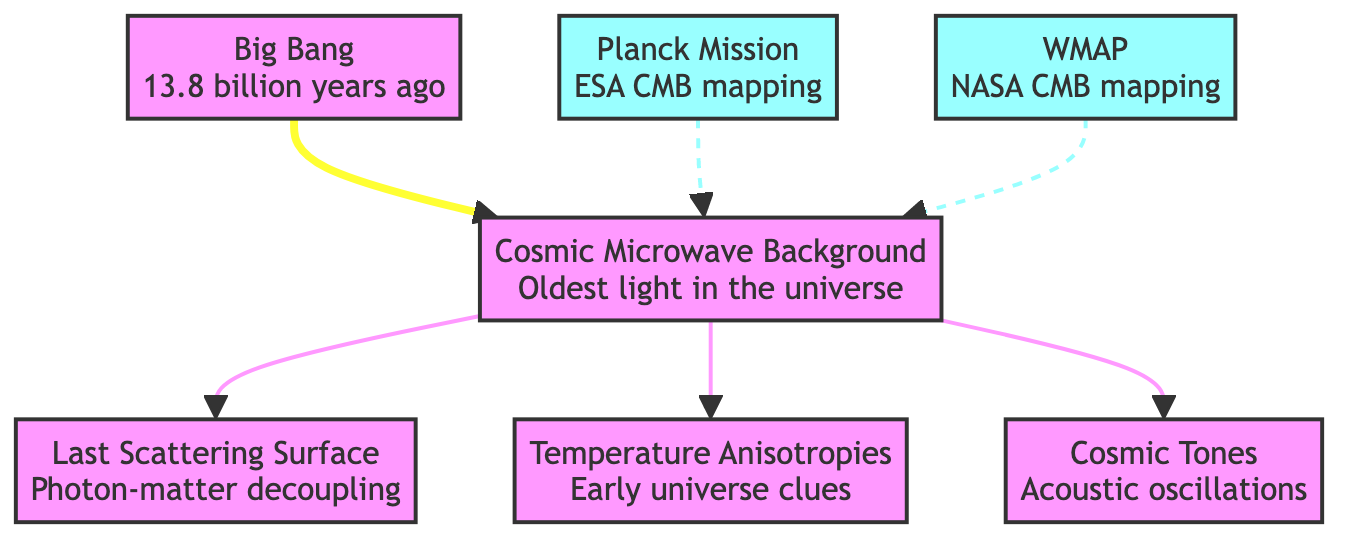What is the event that occurred 13.8 billion years ago? The diagram indicates that the Big Bang happened 13.8 billion years ago, as stated in the node labeled "Big Bang."
Answer: Big Bang What does CMB stand for? The acronym CMB in the diagram represents the "Cosmic Microwave Background," which is defined in its respective node.
Answer: Cosmic Microwave Background How many missions contributed to mapping the CMB? The diagram shows two missions, which are the Planck Mission and WMAP, indicating their contributions to CMB mapping.
Answer: 2 What type of surface is represented by LSS? The node labeled LSS defines it as the "Last Scattering Surface," which provides information about photon-matter decoupling.
Answer: Last Scattering Surface What are Temperature Anisotropies? The node labeled TA describes Temperature Anisotropies as clues from the early universe, providing insight into its conditions.
Answer: Early universe clues Which missions are indicated in the diagram? The diagram displays two missions, which are the Planck Mission and WMAP, each linked to the Cosmic Microwave Background.
Answer: Planck Mission and WMAP What are Cosmic Tones related to in the diagram? The node labeled CT defines Cosmic Tones as relating to acoustic oscillations, indicating a connection to sound in the cosmic context.
Answer: Acoustic oscillations What type of information does the box with Temperature Anisotropies (TA) provide? The diagram links Temperature Anisotropies directly to early universe clues, highlighting the significance of these variations in temperature.
Answer: Early universe clues What connects the Big Bang and the Cosmic Microwave Background? The diagram shows a direct flow from the Big Bang to the Cosmic Microwave Background, indicating that the CMB is a consequence of the Big Bang.
Answer: CMB 